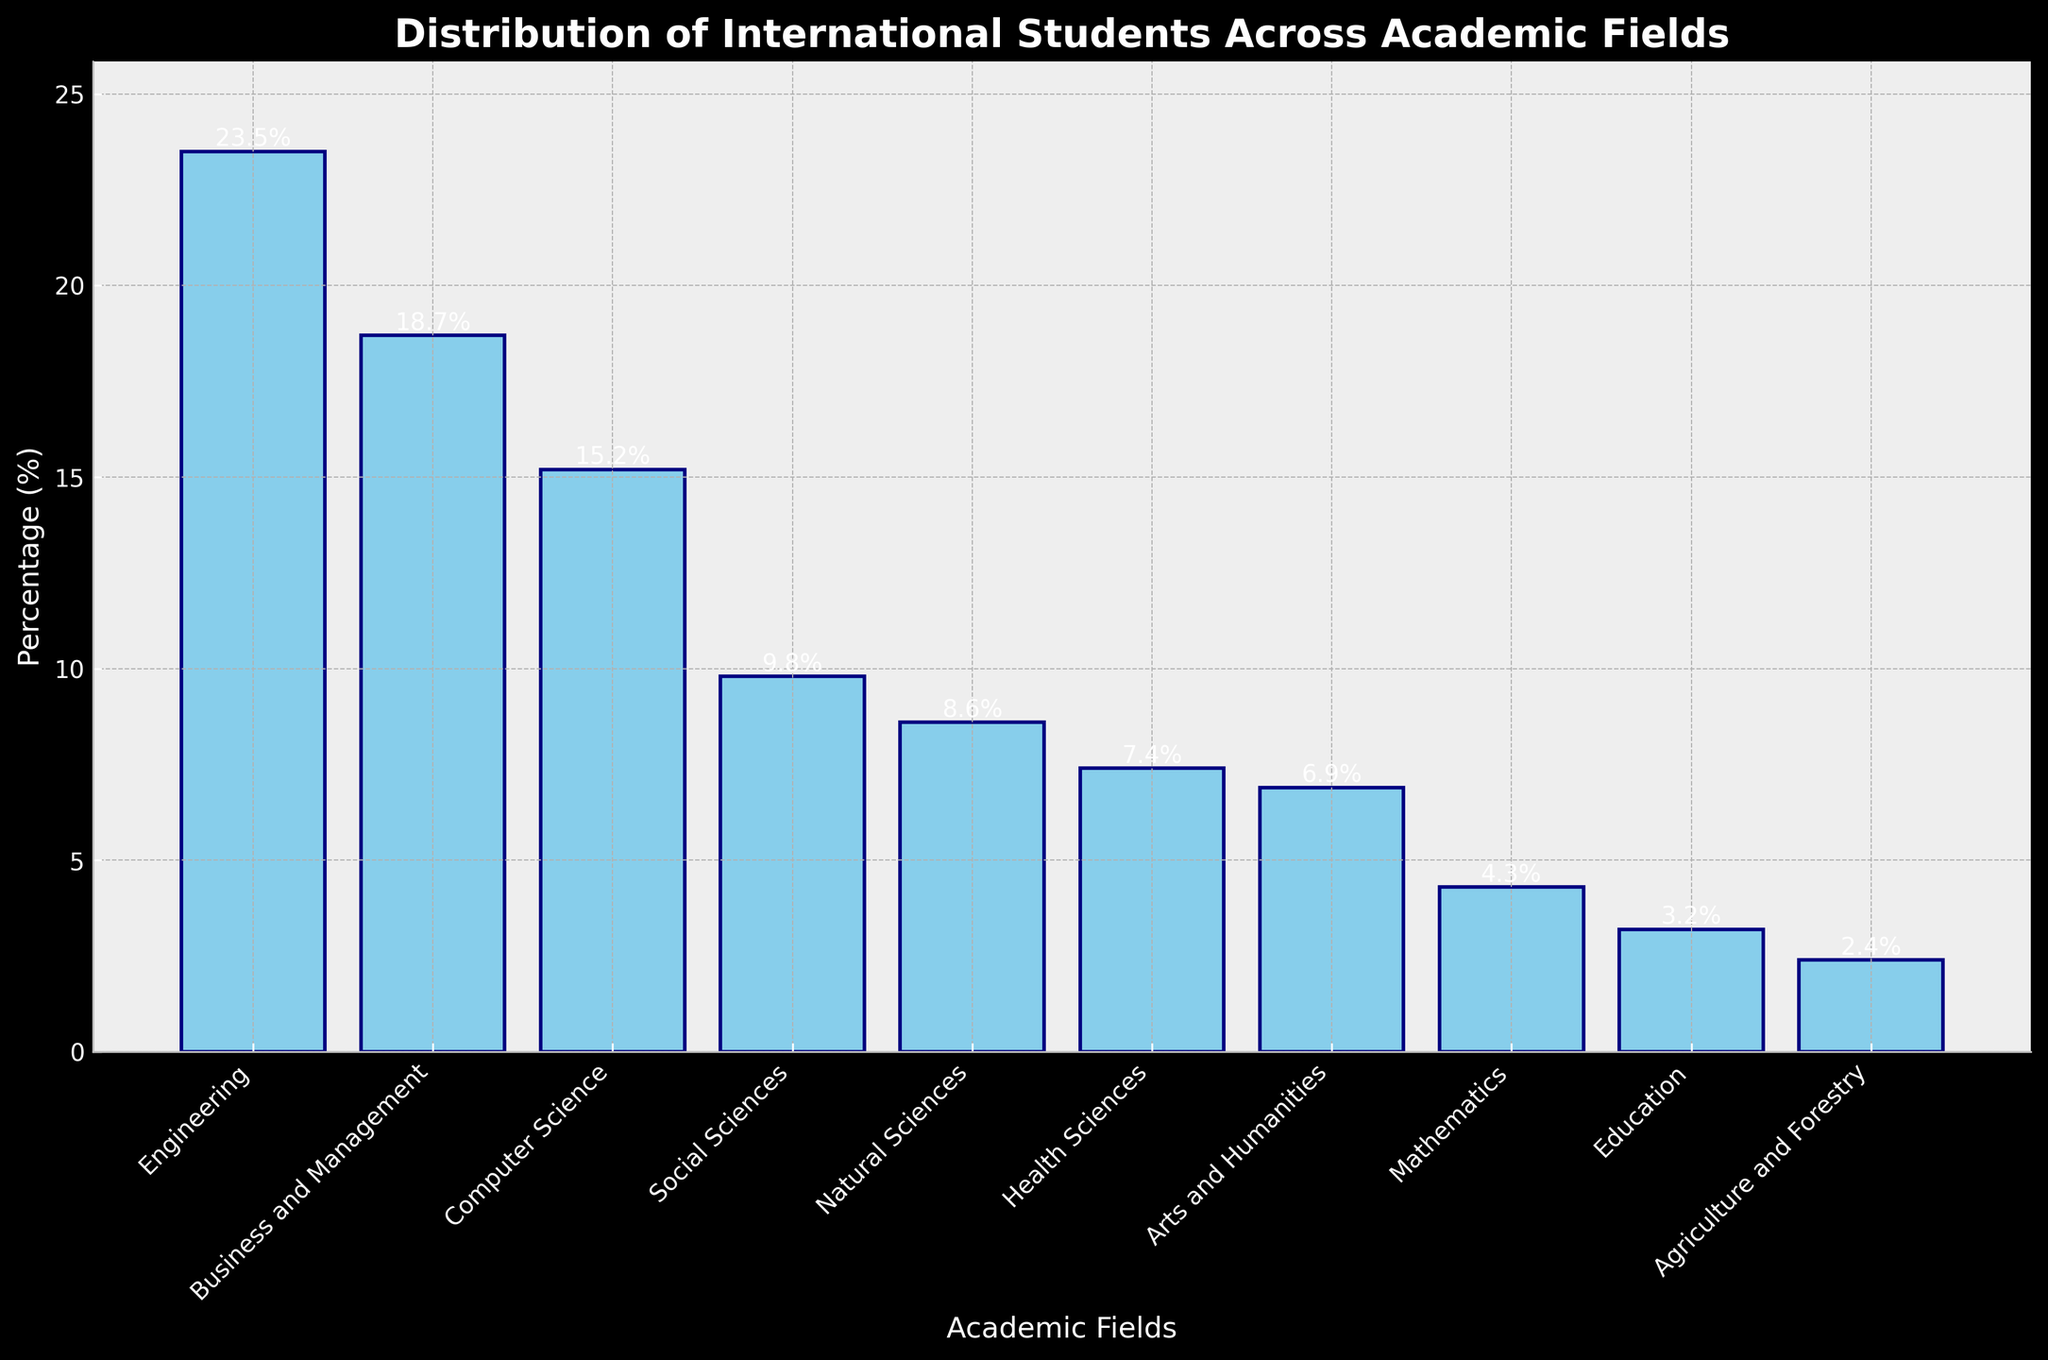Which academic field has the highest percentage of international students? Look at the bar heights and find the tallest bar which represents the highest percentage. The tallest bar corresponds to Engineering.
Answer: Engineering Which academic fields have less than 5% of international students? Identify the bars that are below the 5% mark on the y-axis. These fields are Mathematics, Education, and Agriculture and Forestry.
Answer: Mathematics, Education, Agriculture and Forestry What is the combined percentage of international students in Business and Management and Computer Science? Add the percentages for Business and Management (18.7%) and Computer Science (15.2%). The sum is 18.7 + 15.2 = 33.9.
Answer: 33.9% What is the difference in percentage of international students between Social Sciences and Natural Sciences? Subtract the percentage for Natural Sciences (8.6%) from Social Sciences (9.8%). The difference is 9.8 - 8.6 = 1.2.
Answer: 1.2% What percentage of international students study fields other than Engineering, Business and Management, and Computer Science? Subtract the combined percentage of these three fields from 100%. The combined percentage is 23.5% (Engineering) + 18.7% (Business and Management) + 15.2% (Computer Science) = 57.4%. The remaining percentage is 100% - 57.4% = 42.6%.
Answer: 42.6% Which field has just a slightly higher percentage of international students than Health Sciences? Identify the bars for Health Sciences (7.4%) and find the next higher bar which is Arts and Humanities (6.9%). However, Social Sciences (9.8%) is also close but slightly higher than Health Sciences.
Answer: Social Sciences Which two fields have the smallest visual difference in their international student percentages? Look at the bars with minimal height difference between them. The fields with the smallest difference are Natural Sciences (8.6%) and Health Sciences (7.4%) with a difference of 1.2%.
Answer: Natural Sciences and Health Sciences 